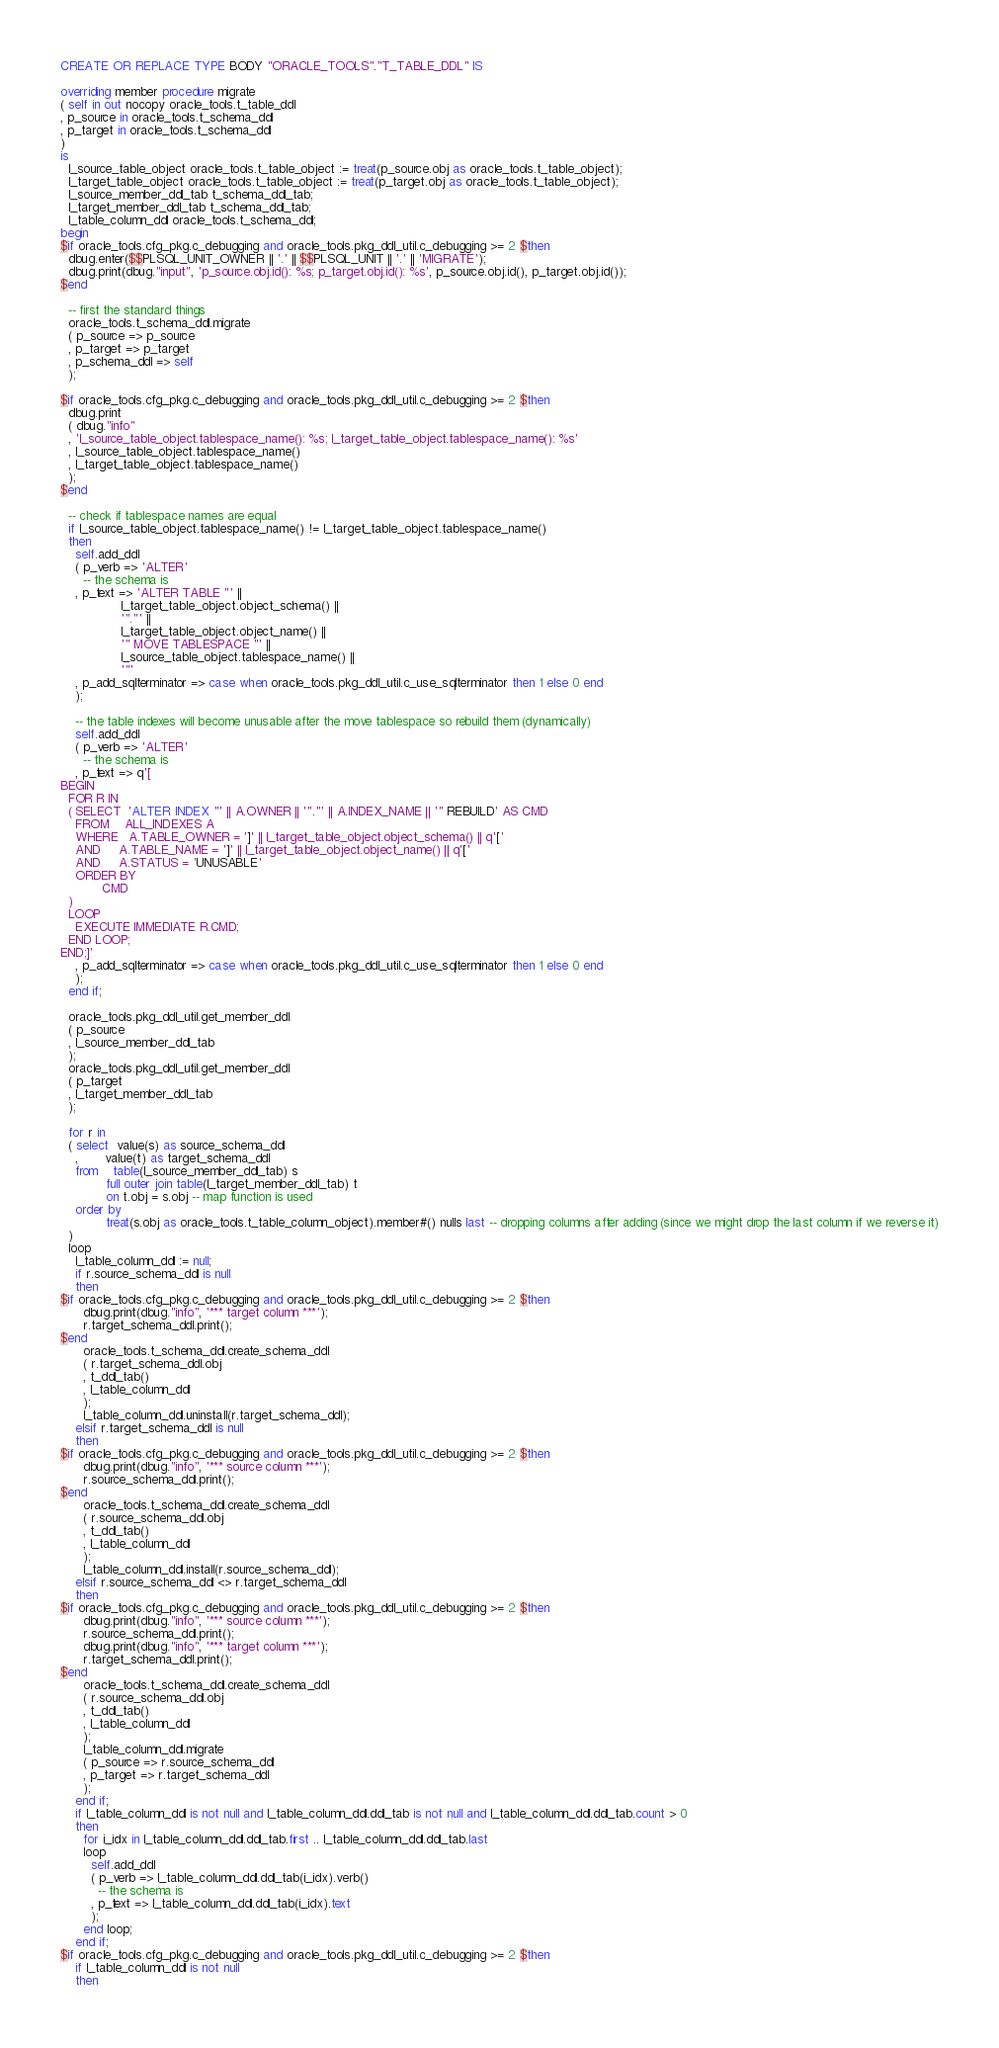<code> <loc_0><loc_0><loc_500><loc_500><_SQL_>CREATE OR REPLACE TYPE BODY "ORACLE_TOOLS"."T_TABLE_DDL" IS

overriding member procedure migrate
( self in out nocopy oracle_tools.t_table_ddl
, p_source in oracle_tools.t_schema_ddl
, p_target in oracle_tools.t_schema_ddl
)
is
  l_source_table_object oracle_tools.t_table_object := treat(p_source.obj as oracle_tools.t_table_object);
  l_target_table_object oracle_tools.t_table_object := treat(p_target.obj as oracle_tools.t_table_object);
  l_source_member_ddl_tab t_schema_ddl_tab;
  l_target_member_ddl_tab t_schema_ddl_tab;
  l_table_column_ddl oracle_tools.t_schema_ddl;
begin
$if oracle_tools.cfg_pkg.c_debugging and oracle_tools.pkg_ddl_util.c_debugging >= 2 $then
  dbug.enter($$PLSQL_UNIT_OWNER || '.' || $$PLSQL_UNIT || '.' || 'MIGRATE');
  dbug.print(dbug."input", 'p_source.obj.id(): %s; p_target.obj.id(): %s', p_source.obj.id(), p_target.obj.id());
$end

  -- first the standard things
  oracle_tools.t_schema_ddl.migrate
  ( p_source => p_source
  , p_target => p_target
  , p_schema_ddl => self
  );

$if oracle_tools.cfg_pkg.c_debugging and oracle_tools.pkg_ddl_util.c_debugging >= 2 $then
  dbug.print
  ( dbug."info"
  , 'l_source_table_object.tablespace_name(): %s; l_target_table_object.tablespace_name(): %s'
  , l_source_table_object.tablespace_name()
  , l_target_table_object.tablespace_name()
  );
$end

  -- check if tablespace names are equal
  if l_source_table_object.tablespace_name() != l_target_table_object.tablespace_name() 
  then
    self.add_ddl
    ( p_verb => 'ALTER'
      -- the schema is
    , p_text => 'ALTER TABLE "' ||
                l_target_table_object.object_schema() ||
                '"."' ||
                l_target_table_object.object_name() ||
                '" MOVE TABLESPACE "' ||
                l_source_table_object.tablespace_name() ||
                '"'
    , p_add_sqlterminator => case when oracle_tools.pkg_ddl_util.c_use_sqlterminator then 1 else 0 end
    );

    -- the table indexes will become unusable after the move tablespace so rebuild them (dynamically)
    self.add_ddl
    ( p_verb => 'ALTER'
      -- the schema is
    , p_text => q'[
BEGIN
  FOR R IN
  ( SELECT  'ALTER INDEX "' || A.OWNER || '"."' || A.INDEX_NAME || '" REBUILD' AS CMD
    FROM    ALL_INDEXES A
    WHERE   A.TABLE_OWNER = ']' || l_target_table_object.object_schema() || q'['
    AND     A.TABLE_NAME = ']' || l_target_table_object.object_name() || q'['
    AND     A.STATUS = 'UNUSABLE'
    ORDER BY 
           CMD
  )
  LOOP
    EXECUTE IMMEDIATE R.CMD;
  END LOOP;
END;]'
    , p_add_sqlterminator => case when oracle_tools.pkg_ddl_util.c_use_sqlterminator then 1 else 0 end
    );
  end if;

  oracle_tools.pkg_ddl_util.get_member_ddl
  ( p_source
  , l_source_member_ddl_tab
  );
  oracle_tools.pkg_ddl_util.get_member_ddl
  ( p_target
  , l_target_member_ddl_tab
  );

  for r in
  ( select  value(s) as source_schema_ddl
    ,       value(t) as target_schema_ddl
    from    table(l_source_member_ddl_tab) s
            full outer join table(l_target_member_ddl_tab) t
            on t.obj = s.obj -- map function is used
    order by
            treat(s.obj as oracle_tools.t_table_column_object).member#() nulls last -- dropping columns after adding (since we might drop the last column if we reverse it)
  )
  loop
    l_table_column_ddl := null;
    if r.source_schema_ddl is null
    then
$if oracle_tools.cfg_pkg.c_debugging and oracle_tools.pkg_ddl_util.c_debugging >= 2 $then
      dbug.print(dbug."info", '*** target column ***');
      r.target_schema_ddl.print();
$end      
      oracle_tools.t_schema_ddl.create_schema_ddl
      ( r.target_schema_ddl.obj
      , t_ddl_tab()
      , l_table_column_ddl
      );
      l_table_column_ddl.uninstall(r.target_schema_ddl);
    elsif r.target_schema_ddl is null
    then
$if oracle_tools.cfg_pkg.c_debugging and oracle_tools.pkg_ddl_util.c_debugging >= 2 $then
      dbug.print(dbug."info", '*** source column ***');
      r.source_schema_ddl.print();
$end      
      oracle_tools.t_schema_ddl.create_schema_ddl
      ( r.source_schema_ddl.obj
      , t_ddl_tab()
      , l_table_column_ddl
      );
      l_table_column_ddl.install(r.source_schema_ddl);
    elsif r.source_schema_ddl <> r.target_schema_ddl
    then
$if oracle_tools.cfg_pkg.c_debugging and oracle_tools.pkg_ddl_util.c_debugging >= 2 $then
      dbug.print(dbug."info", '*** source column ***');
      r.source_schema_ddl.print();
      dbug.print(dbug."info", '*** target column ***');
      r.target_schema_ddl.print();
$end      
      oracle_tools.t_schema_ddl.create_schema_ddl
      ( r.source_schema_ddl.obj
      , t_ddl_tab()
      , l_table_column_ddl
      );
      l_table_column_ddl.migrate
      ( p_source => r.source_schema_ddl
      , p_target => r.target_schema_ddl
      );
    end if;
    if l_table_column_ddl is not null and l_table_column_ddl.ddl_tab is not null and l_table_column_ddl.ddl_tab.count > 0
    then
      for i_idx in l_table_column_ddl.ddl_tab.first .. l_table_column_ddl.ddl_tab.last
      loop
        self.add_ddl
        ( p_verb => l_table_column_ddl.ddl_tab(i_idx).verb()
          -- the schema is
        , p_text => l_table_column_ddl.ddl_tab(i_idx).text
        );
      end loop;
    end if;
$if oracle_tools.cfg_pkg.c_debugging and oracle_tools.pkg_ddl_util.c_debugging >= 2 $then
    if l_table_column_ddl is not null
    then</code> 